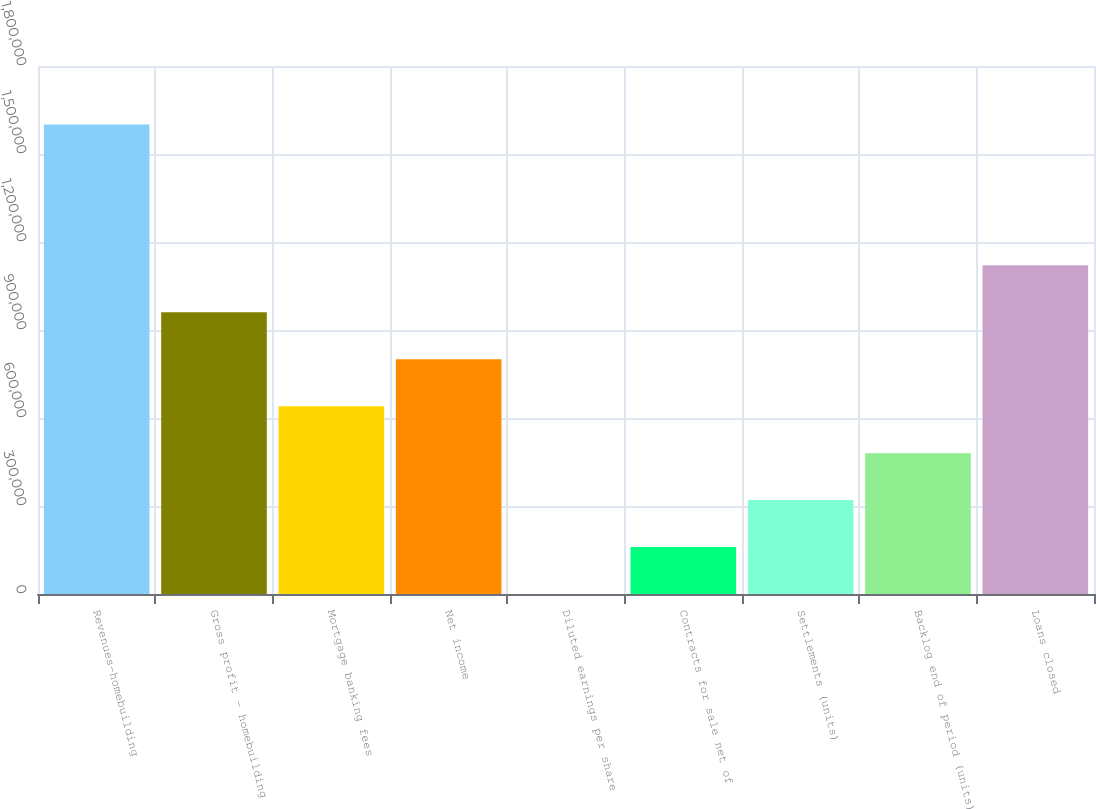<chart> <loc_0><loc_0><loc_500><loc_500><bar_chart><fcel>Revenues-homebuilding<fcel>Gross profit - homebuilding<fcel>Mortgage banking fees<fcel>Net income<fcel>Diluted earnings per share<fcel>Contracts for sale net of<fcel>Settlements (units)<fcel>Backlog end of period (units)<fcel>Loans closed<nl><fcel>1.60073e+06<fcel>960448<fcel>640306<fcel>800377<fcel>20.86<fcel>160092<fcel>320163<fcel>480234<fcel>1.12052e+06<nl></chart> 